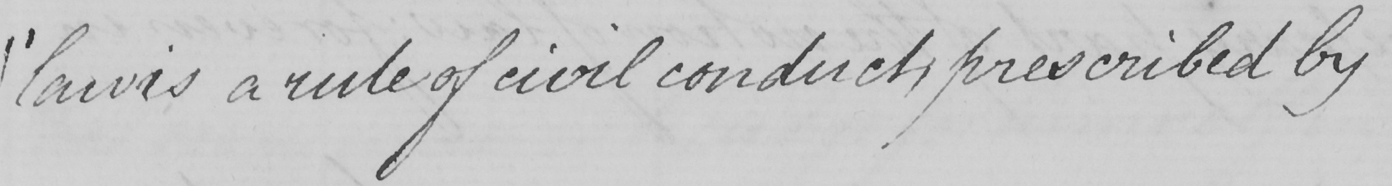What does this handwritten line say? " law is a rule of civil conduct , prescribed by 